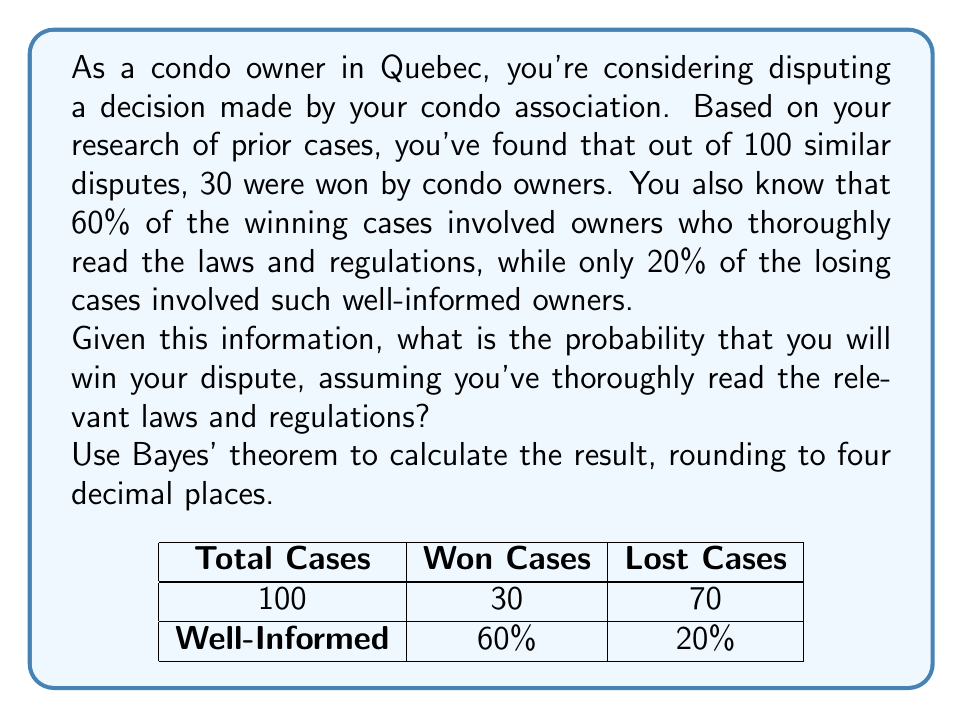Can you answer this question? Let's approach this step-by-step using Bayes' theorem:

1. Define the events:
   W: Winning the dispute
   R: Thoroughly reading laws and regulations

2. Given information:
   P(W) = 30/100 = 0.3 (prior probability of winning)
   P(R|W) = 0.6 (probability of reading given a win)
   P(R|not W) = 0.2 (probability of reading given a loss)

3. Bayes' theorem:
   $$P(W|R) = \frac{P(R|W) \cdot P(W)}{P(R)}$$

4. Calculate P(R) using the law of total probability:
   $$P(R) = P(R|W) \cdot P(W) + P(R|not W) \cdot P(not W)$$
   $$P(R) = 0.6 \cdot 0.3 + 0.2 \cdot 0.7 = 0.18 + 0.14 = 0.32$$

5. Now we can apply Bayes' theorem:
   $$P(W|R) = \frac{0.6 \cdot 0.3}{0.32} = \frac{0.18}{0.32} = 0.5625$$

6. Rounding to four decimal places:
   P(W|R) ≈ 0.5625
Answer: 0.5625 